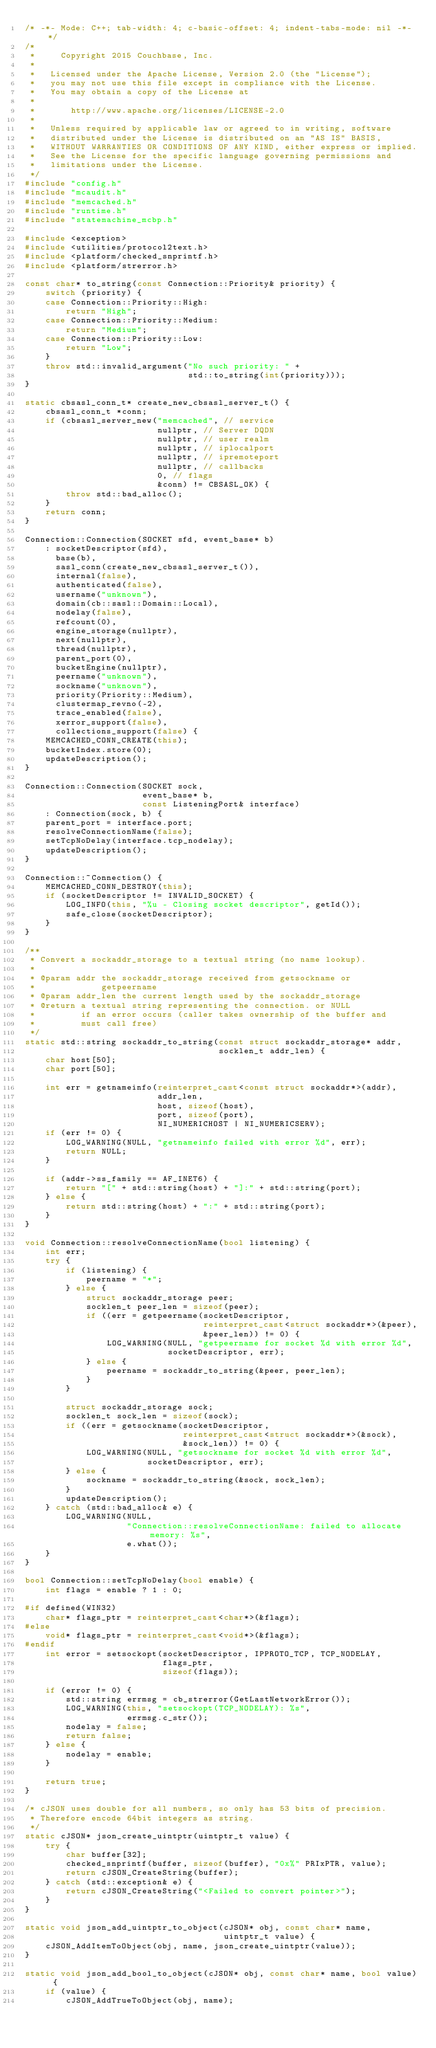Convert code to text. <code><loc_0><loc_0><loc_500><loc_500><_C++_>/* -*- Mode: C++; tab-width: 4; c-basic-offset: 4; indent-tabs-mode: nil -*- */
/*
 *     Copyright 2015 Couchbase, Inc.
 *
 *   Licensed under the Apache License, Version 2.0 (the "License");
 *   you may not use this file except in compliance with the License.
 *   You may obtain a copy of the License at
 *
 *       http://www.apache.org/licenses/LICENSE-2.0
 *
 *   Unless required by applicable law or agreed to in writing, software
 *   distributed under the License is distributed on an "AS IS" BASIS,
 *   WITHOUT WARRANTIES OR CONDITIONS OF ANY KIND, either express or implied.
 *   See the License for the specific language governing permissions and
 *   limitations under the License.
 */
#include "config.h"
#include "mcaudit.h"
#include "memcached.h"
#include "runtime.h"
#include "statemachine_mcbp.h"

#include <exception>
#include <utilities/protocol2text.h>
#include <platform/checked_snprintf.h>
#include <platform/strerror.h>

const char* to_string(const Connection::Priority& priority) {
    switch (priority) {
    case Connection::Priority::High:
        return "High";
    case Connection::Priority::Medium:
        return "Medium";
    case Connection::Priority::Low:
        return "Low";
    }
    throw std::invalid_argument("No such priority: " +
                                std::to_string(int(priority)));
}

static cbsasl_conn_t* create_new_cbsasl_server_t() {
    cbsasl_conn_t *conn;
    if (cbsasl_server_new("memcached", // service
                          nullptr, // Server DQDN
                          nullptr, // user realm
                          nullptr, // iplocalport
                          nullptr, // ipremoteport
                          nullptr, // callbacks
                          0, // flags
                          &conn) != CBSASL_OK) {
        throw std::bad_alloc();
    }
    return conn;
}

Connection::Connection(SOCKET sfd, event_base* b)
    : socketDescriptor(sfd),
      base(b),
      sasl_conn(create_new_cbsasl_server_t()),
      internal(false),
      authenticated(false),
      username("unknown"),
      domain(cb::sasl::Domain::Local),
      nodelay(false),
      refcount(0),
      engine_storage(nullptr),
      next(nullptr),
      thread(nullptr),
      parent_port(0),
      bucketEngine(nullptr),
      peername("unknown"),
      sockname("unknown"),
      priority(Priority::Medium),
      clustermap_revno(-2),
      trace_enabled(false),
      xerror_support(false),
      collections_support(false) {
    MEMCACHED_CONN_CREATE(this);
    bucketIndex.store(0);
    updateDescription();
}

Connection::Connection(SOCKET sock,
                       event_base* b,
                       const ListeningPort& interface)
    : Connection(sock, b) {
    parent_port = interface.port;
    resolveConnectionName(false);
    setTcpNoDelay(interface.tcp_nodelay);
    updateDescription();
}

Connection::~Connection() {
    MEMCACHED_CONN_DESTROY(this);
    if (socketDescriptor != INVALID_SOCKET) {
        LOG_INFO(this, "%u - Closing socket descriptor", getId());
        safe_close(socketDescriptor);
    }
}

/**
 * Convert a sockaddr_storage to a textual string (no name lookup).
 *
 * @param addr the sockaddr_storage received from getsockname or
 *             getpeername
 * @param addr_len the current length used by the sockaddr_storage
 * @return a textual string representing the connection. or NULL
 *         if an error occurs (caller takes ownership of the buffer and
 *         must call free)
 */
static std::string sockaddr_to_string(const struct sockaddr_storage* addr,
                                      socklen_t addr_len) {
    char host[50];
    char port[50];

    int err = getnameinfo(reinterpret_cast<const struct sockaddr*>(addr),
                          addr_len,
                          host, sizeof(host),
                          port, sizeof(port),
                          NI_NUMERICHOST | NI_NUMERICSERV);
    if (err != 0) {
        LOG_WARNING(NULL, "getnameinfo failed with error %d", err);
        return NULL;
    }

    if (addr->ss_family == AF_INET6) {
        return "[" + std::string(host) + "]:" + std::string(port);
    } else {
        return std::string(host) + ":" + std::string(port);
    }
}

void Connection::resolveConnectionName(bool listening) {
    int err;
    try {
        if (listening) {
            peername = "*";
        } else {
            struct sockaddr_storage peer;
            socklen_t peer_len = sizeof(peer);
            if ((err = getpeername(socketDescriptor,
                                   reinterpret_cast<struct sockaddr*>(&peer),
                                   &peer_len)) != 0) {
                LOG_WARNING(NULL, "getpeername for socket %d with error %d",
                            socketDescriptor, err);
            } else {
                peername = sockaddr_to_string(&peer, peer_len);
            }
        }

        struct sockaddr_storage sock;
        socklen_t sock_len = sizeof(sock);
        if ((err = getsockname(socketDescriptor,
                               reinterpret_cast<struct sockaddr*>(&sock),
                               &sock_len)) != 0) {
            LOG_WARNING(NULL, "getsockname for socket %d with error %d",
                        socketDescriptor, err);
        } else {
            sockname = sockaddr_to_string(&sock, sock_len);
        }
        updateDescription();
    } catch (std::bad_alloc& e) {
        LOG_WARNING(NULL,
                    "Connection::resolveConnectionName: failed to allocate memory: %s",
                    e.what());
    }
}

bool Connection::setTcpNoDelay(bool enable) {
    int flags = enable ? 1 : 0;

#if defined(WIN32)
    char* flags_ptr = reinterpret_cast<char*>(&flags);
#else
    void* flags_ptr = reinterpret_cast<void*>(&flags);
#endif
    int error = setsockopt(socketDescriptor, IPPROTO_TCP, TCP_NODELAY,
                           flags_ptr,
                           sizeof(flags));

    if (error != 0) {
        std::string errmsg = cb_strerror(GetLastNetworkError());
        LOG_WARNING(this, "setsockopt(TCP_NODELAY): %s",
                    errmsg.c_str());
        nodelay = false;
        return false;
    } else {
        nodelay = enable;
    }

    return true;
}

/* cJSON uses double for all numbers, so only has 53 bits of precision.
 * Therefore encode 64bit integers as string.
 */
static cJSON* json_create_uintptr(uintptr_t value) {
    try {
        char buffer[32];
        checked_snprintf(buffer, sizeof(buffer), "0x%" PRIxPTR, value);
        return cJSON_CreateString(buffer);
    } catch (std::exception& e) {
        return cJSON_CreateString("<Failed to convert pointer>");
    }
}

static void json_add_uintptr_to_object(cJSON* obj, const char* name,
                                       uintptr_t value) {
    cJSON_AddItemToObject(obj, name, json_create_uintptr(value));
}

static void json_add_bool_to_object(cJSON* obj, const char* name, bool value) {
    if (value) {
        cJSON_AddTrueToObject(obj, name);</code> 